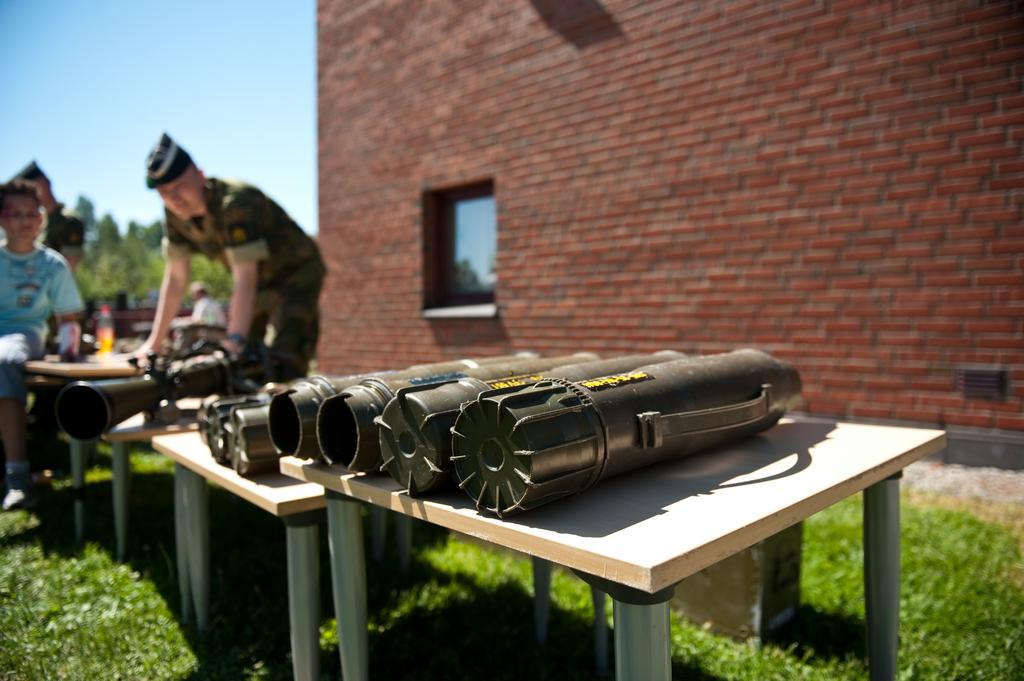What can be seen on the tables in the image? There are objects on the tables in the image. Who or what can be seen in the image besides the tables? There are people and plants in the image. What type of vegetation is present in the image? There are trees in the image. What is visible in the background of the image? The sky is visible in the background of the image. What is the setting of the image? The image features a wall, suggesting an indoor or outdoor space with a walled area. Can you tell me how many grapes are on the table in the image? There is no mention of grapes in the image; the objects on the tables are not specified. What is the interest of the people in the image? There is no information about the interests of the people in the image. Are there any giants present in the image? There is no mention of giants in the image; the people present are not described as being of unusual size. 